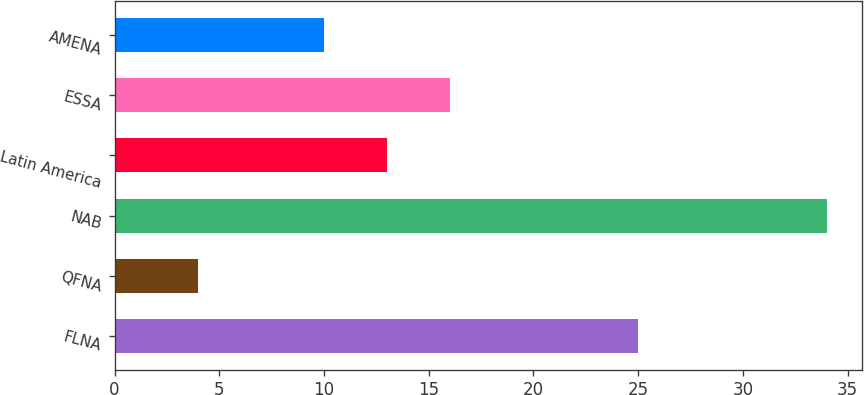<chart> <loc_0><loc_0><loc_500><loc_500><bar_chart><fcel>FLNA<fcel>QFNA<fcel>NAB<fcel>Latin America<fcel>ESSA<fcel>AMENA<nl><fcel>25<fcel>4<fcel>34<fcel>13<fcel>16<fcel>10<nl></chart> 